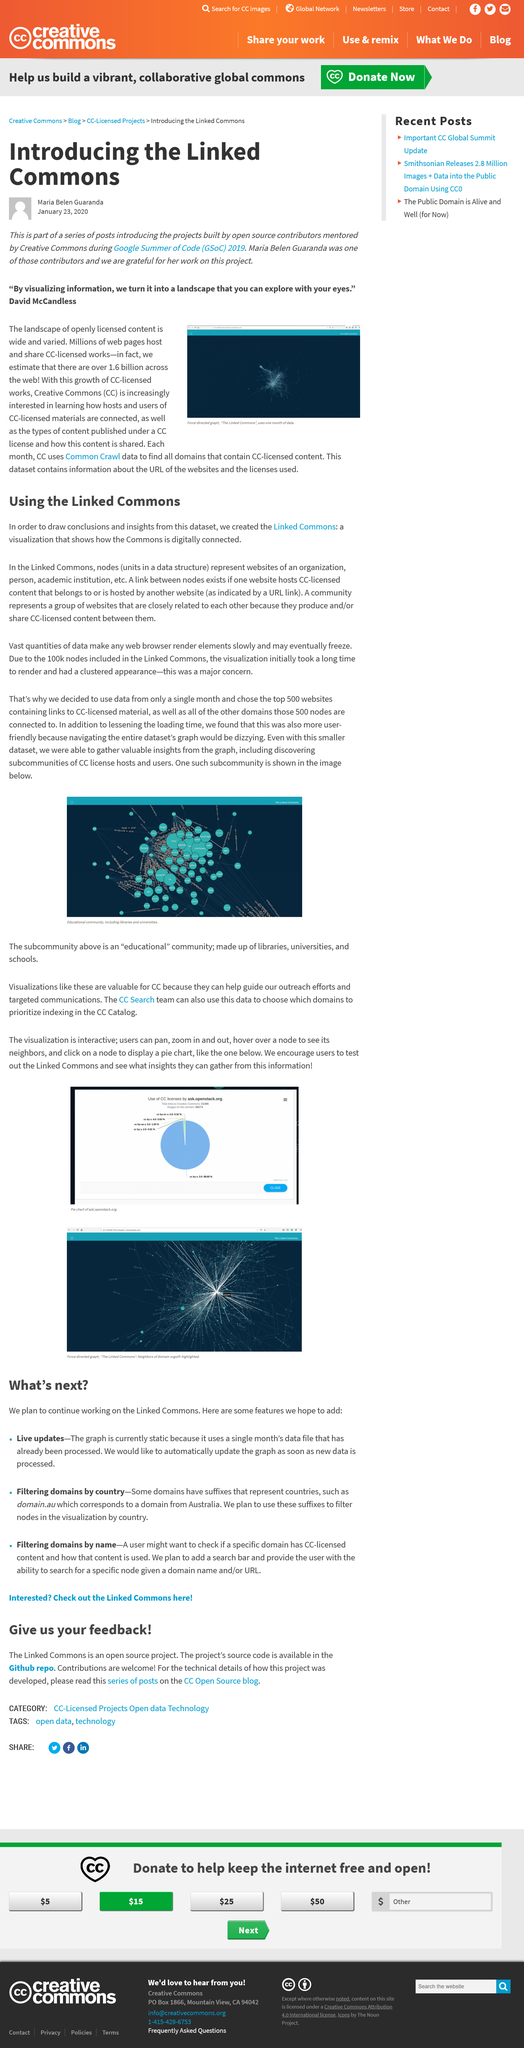Indicate a few pertinent items in this graphic. A link between nodes exists when a website hosts CC-licensed content that belongs to or is hosted by another website, as indicated by a URL link. A 'Linked Commons' is a visualization that illustrates the interconnectedness of the digital Commons, showcasing the various ways in which these resources are linked and accessible to users. A community represents a collection of websites that share a common interest in producing and/or sharing CC-licensed content, and are united by their shared purpose and values. 